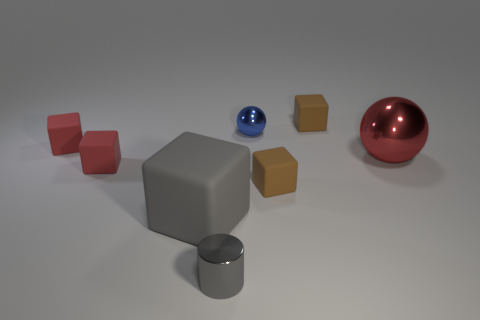Is there any other thing that is the same size as the blue object?
Your answer should be compact. Yes. Is there anything else that is made of the same material as the blue ball?
Your answer should be compact. Yes. There is a cylinder; is its color the same as the large thing that is on the right side of the large cube?
Provide a short and direct response. No. What number of other things are made of the same material as the tiny blue sphere?
Provide a succinct answer. 2. Is the number of small brown cubes greater than the number of gray rubber blocks?
Your answer should be compact. Yes. Is the color of the tiny shiny thing that is in front of the big rubber cube the same as the tiny sphere?
Your response must be concise. No. What color is the cylinder?
Give a very brief answer. Gray. There is a tiny metal thing that is behind the small gray cylinder; is there a red metal sphere left of it?
Your answer should be compact. No. What shape is the gray thing that is behind the tiny shiny object in front of the big gray rubber object?
Keep it short and to the point. Cube. Is the number of large red objects less than the number of matte cubes?
Provide a succinct answer. Yes. 